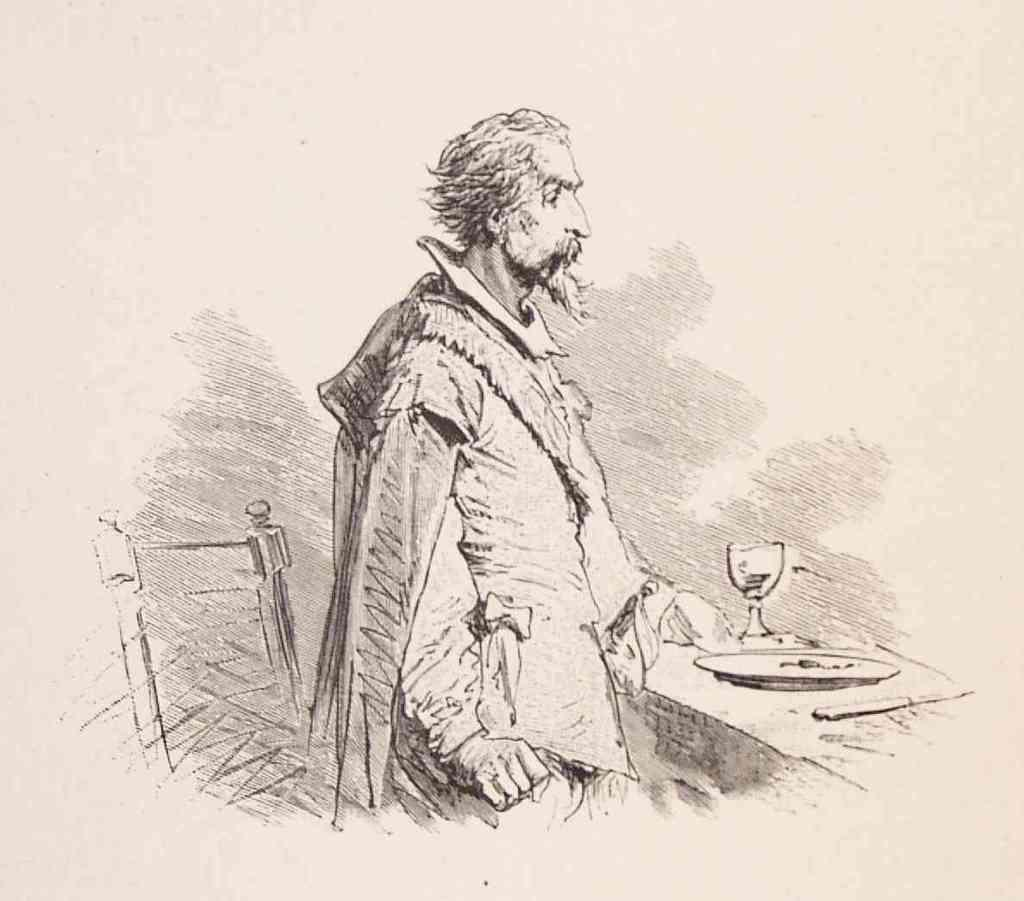What type of artwork is shown in the image? The image is a sketch. What is the main subject of the sketch? The sketch depicts a man. What objects is the man holding in the sketch? The man is holding a plate, a knife, and a glass. What piece of furniture is visible in the image? There is a chair in the image. What is the weather like in the sketch? The sketch is a drawing and does not depict weather conditions. --- Facts: 1. There is a car in the image. 2. The car is red. 3. The car has four wheels. 4. The car has a license plate. 5. The license plate has numbers and letters. Absurd Topics: dance, ocean, bird Conversation: What is the main subject of the image? The main subject of the image is a car. What color is the car? The car is red. How many wheels does the car have? The car has four wheels. What is attached to the back of the car? The car has a license plate. What information is displayed on the license plate? The license plate has numbers and letters. Reasoning: Let's think step by step in order to produce the conversation. We start by identifying the main subject of the image, which is a car. Then, we describe the color of the car, which is red. Next, we mention the number of wheels the car has, which is four. We then focus on the license plate, noting that it is attached to the back of the car and contains numbers and letters. Each question is designed to elicit a specific detail about the image that is known from the provided facts. Absurd Question/Answer: Can you see any birds flying over the ocean in the image? There is no ocean or birds present in the image; it features a red car with a license plate. 